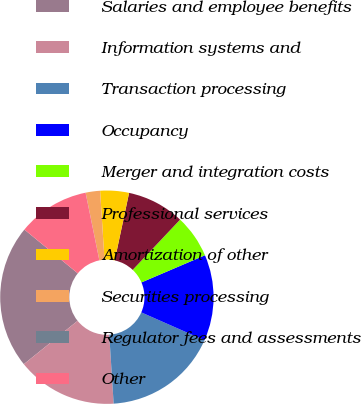Convert chart to OTSL. <chart><loc_0><loc_0><loc_500><loc_500><pie_chart><fcel>Salaries and employee benefits<fcel>Information systems and<fcel>Transaction processing<fcel>Occupancy<fcel>Merger and integration costs<fcel>Professional services<fcel>Amortization of other<fcel>Securities processing<fcel>Regulator fees and assessments<fcel>Other<nl><fcel>21.73%<fcel>15.21%<fcel>17.38%<fcel>13.04%<fcel>6.53%<fcel>8.7%<fcel>4.35%<fcel>2.18%<fcel>0.01%<fcel>10.87%<nl></chart> 